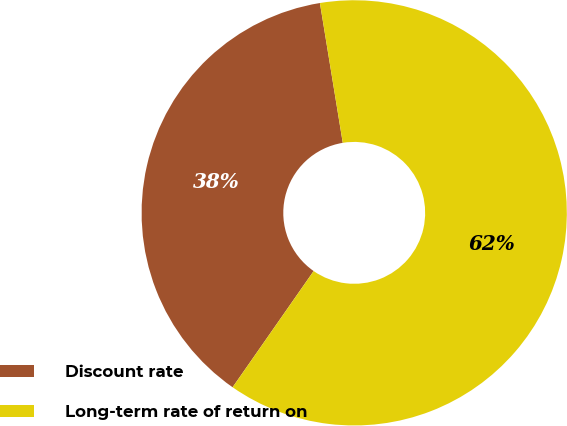Convert chart to OTSL. <chart><loc_0><loc_0><loc_500><loc_500><pie_chart><fcel>Discount rate<fcel>Long-term rate of return on<nl><fcel>37.73%<fcel>62.27%<nl></chart> 